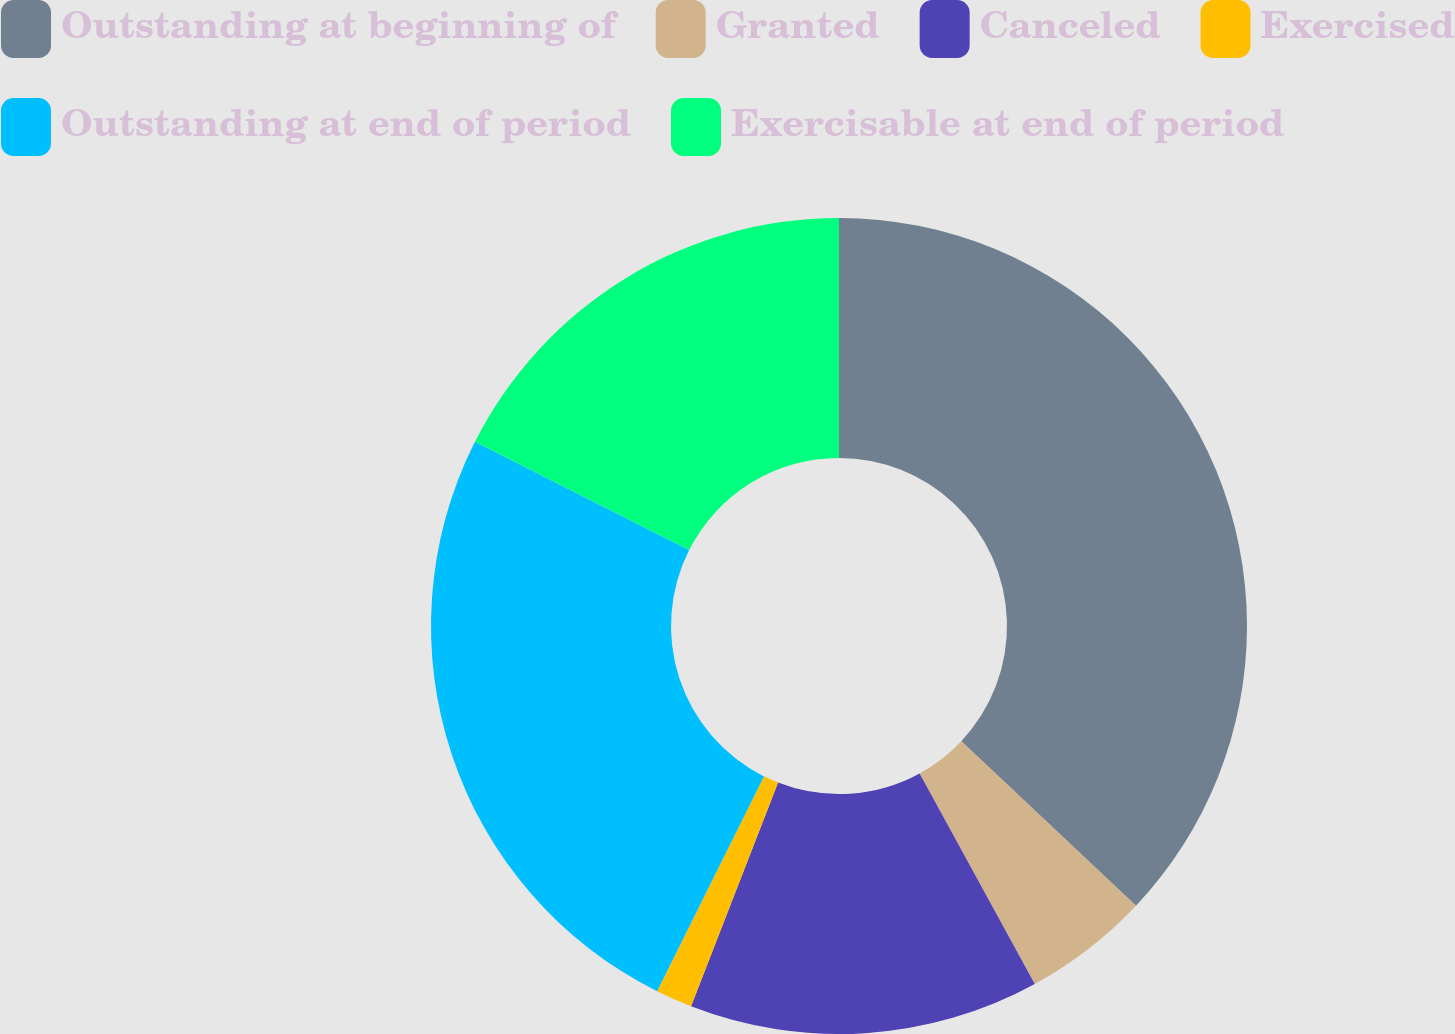Convert chart to OTSL. <chart><loc_0><loc_0><loc_500><loc_500><pie_chart><fcel>Outstanding at beginning of<fcel>Granted<fcel>Canceled<fcel>Exercised<fcel>Outstanding at end of period<fcel>Exercisable at end of period<nl><fcel>37.02%<fcel>5.01%<fcel>13.87%<fcel>1.45%<fcel>25.1%<fcel>17.54%<nl></chart> 